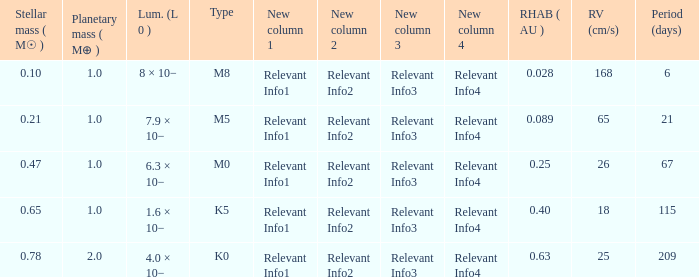What is the highest planetary mass having an RV (cm/s) of 65 and a Period (days) less than 21? None. 